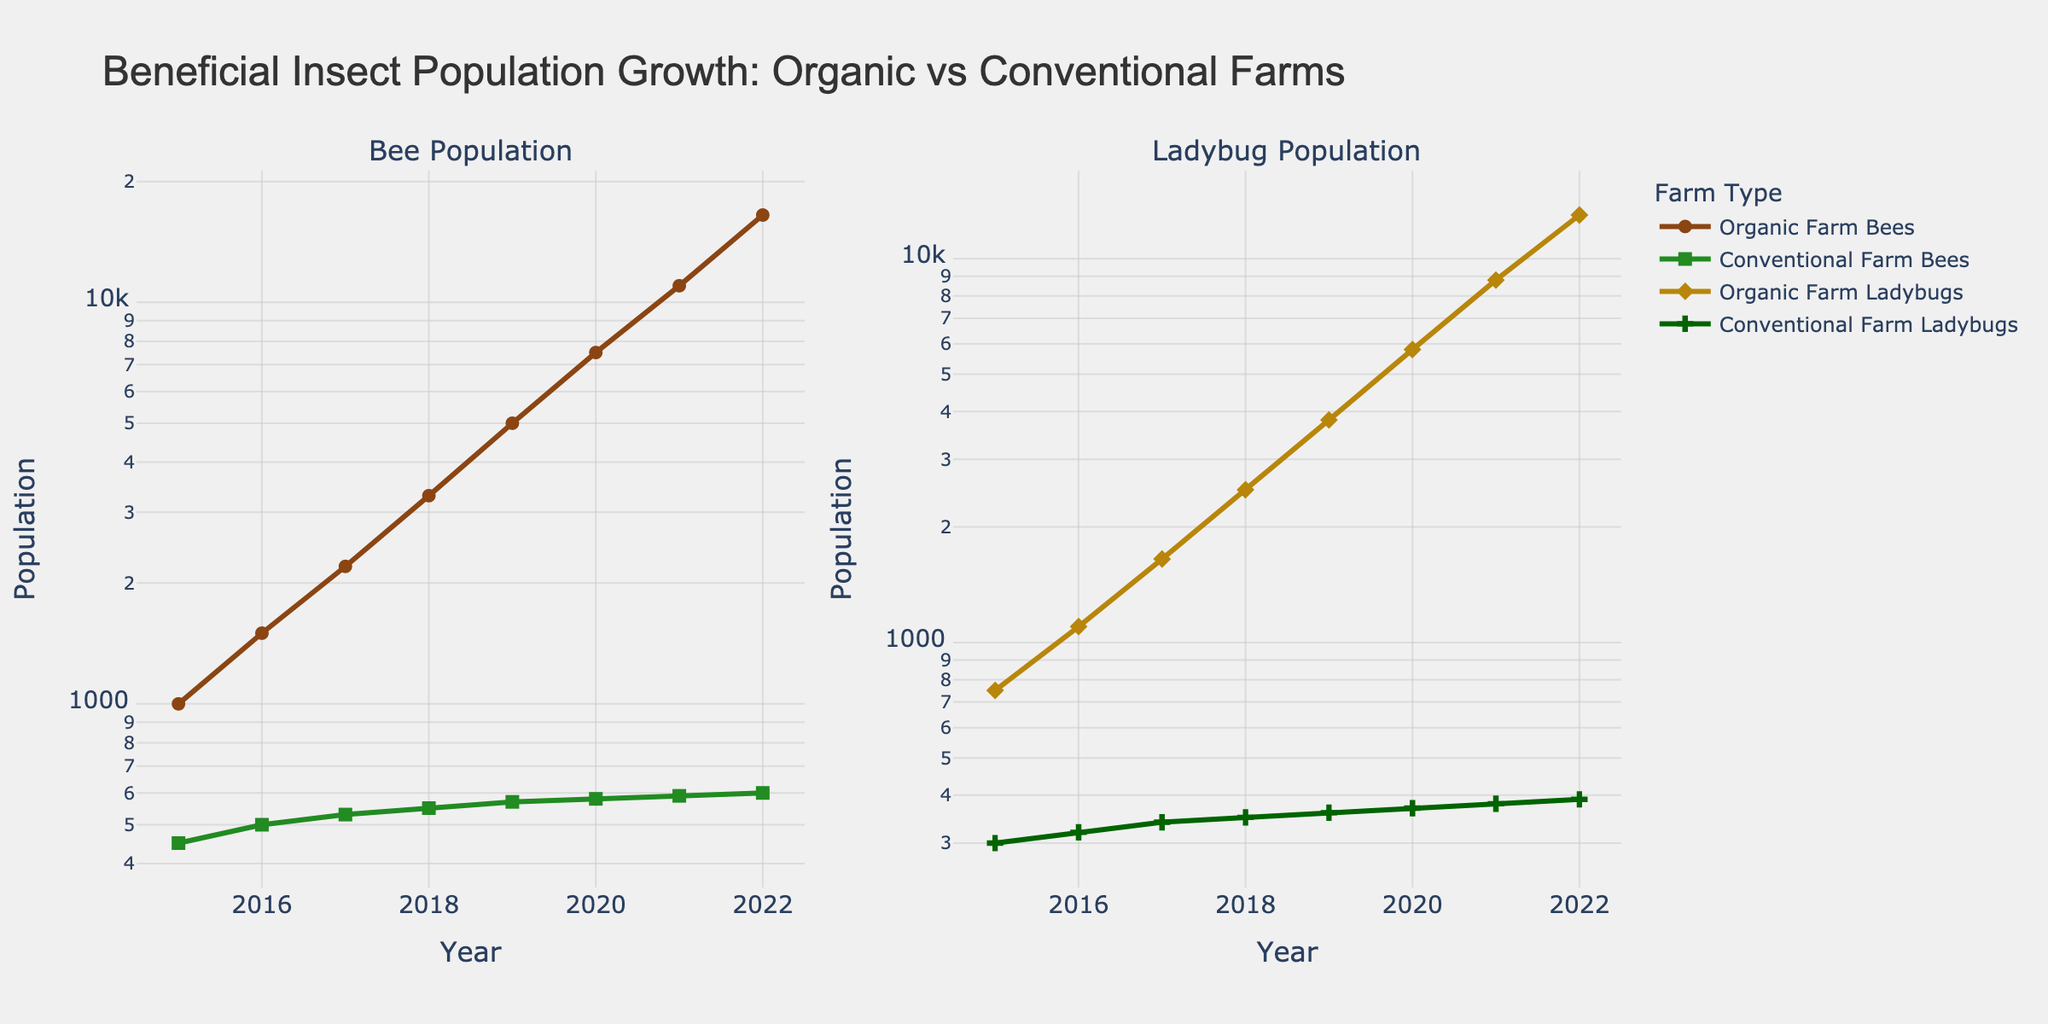Which farm type has a higher bee population at the end of the period, in 2022? Comparing the y-values for bees in 2022, the organic farm shows 16,500 bees, while the conventional farm shows 600 bees, indicating a higher population for the organic farm.
Answer: Organic farm What is the initial population of ladybugs in 2015 for organic farms? The y-value for organic farm ladybugs in 2015 is directly given as 750.
Answer: 750 How does the bee population growth for organic farms compare to that of conventional farms from 2015 to 2022? To compare growth, note the populations in 2015 and 2022 for both farm types and calculate the difference. Organic farms: 16,500 - 1,000 = 15,500. Conventional farms: 600 - 450 = 150. Organic farms had a significantly higher growth.
Answer: Organic farms had a significantly higher growth By what factor did the ladybug population increase in organic farms from 2015 to 2022? The initial population in 2015 was 750, and in 2022 it was 13,000. Divide the final population by the initial population: 13,000 / 750 ≈ 17.33.
Answer: Approximately 17.33 What is the difference in bee population between organic and conventional farms in 2020? For 2020, the organic farm's bee population is 7,500, and the conventional farm's bee population is 580. The difference is 7,500 - 580 = 6,920.
Answer: 6,920 Which insect population shows a more consistent yearly growth in organic farms? By visually inspecting the log-scaled line plots, the bee population shows a smooth and consistent growth pattern compared to the ladybug population, which has some variations.
Answer: Bees How many years did it take for the bee population in organic farms to double from its 2015 value? The initial population in 2015 is 1,000; doubling it is 2,000. This value is surpassed in 2017 when the population reaches 2,200. Therefore, it took 2 years (2015 to 2017).
Answer: 2 years Between 2019 and 2021, which farm type shows a higher ladybug population increase? In 2019, the organic farm's ladybug population is 3,800, and in 2021, it's 8,800. The increase is 5,000. For conventional farms, it increased from 360 to 380 in the same period, which is only 20. Organic farms demonstrate a higher increase.
Answer: Organic farms In what year did the conventional farms achieve their highest recorded bee population? By examining the conventional farm bee line plot, the highest population is seen in 2022 with 600 bees.
Answer: 2022 Which insect population grew faster on organic farms, bees or ladybugs, between 2015 and 2022? Comparing the growth, bees increased from 1,000 to 16,500 (a 15,500 increase) and ladybugs from 750 to 13,000 (a 12,250 increase). The bee population grew by a larger amount.
Answer: Bees 